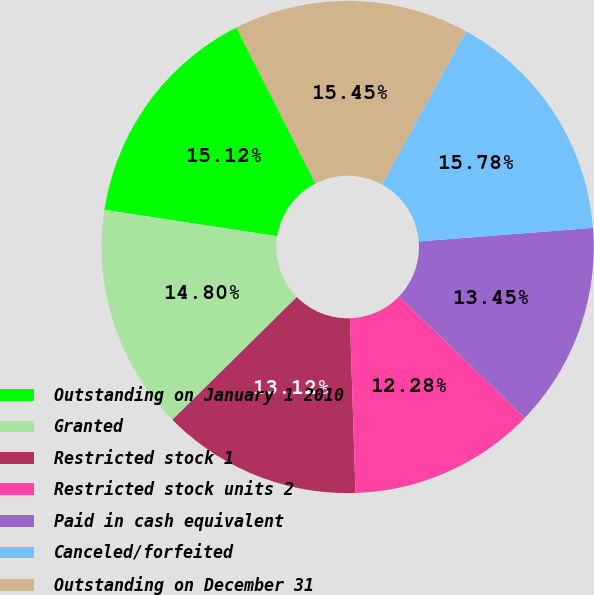Convert chart to OTSL. <chart><loc_0><loc_0><loc_500><loc_500><pie_chart><fcel>Outstanding on January 1 2010<fcel>Granted<fcel>Restricted stock 1<fcel>Restricted stock units 2<fcel>Paid in cash equivalent<fcel>Canceled/forfeited<fcel>Outstanding on December 31<nl><fcel>15.12%<fcel>14.8%<fcel>13.12%<fcel>12.28%<fcel>13.45%<fcel>15.78%<fcel>15.45%<nl></chart> 